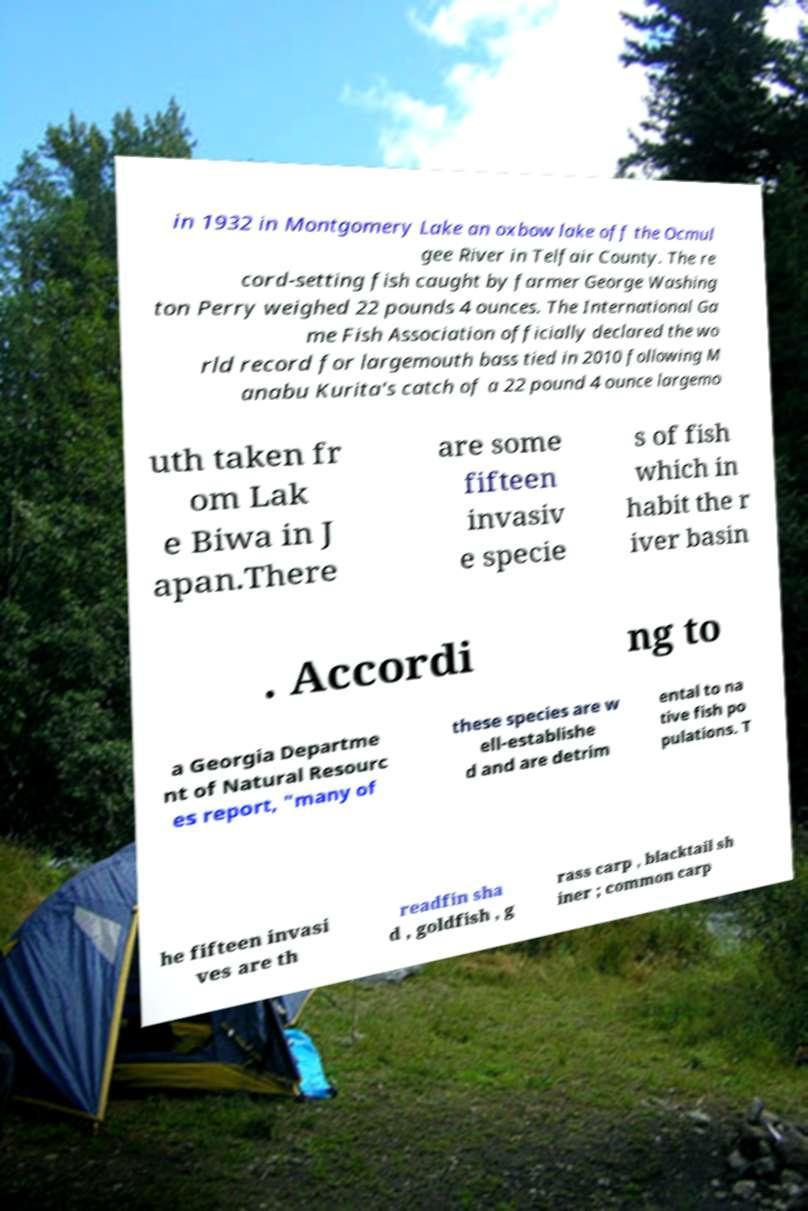Can you read and provide the text displayed in the image?This photo seems to have some interesting text. Can you extract and type it out for me? in 1932 in Montgomery Lake an oxbow lake off the Ocmul gee River in Telfair County. The re cord-setting fish caught by farmer George Washing ton Perry weighed 22 pounds 4 ounces. The International Ga me Fish Association officially declared the wo rld record for largemouth bass tied in 2010 following M anabu Kurita's catch of a 22 pound 4 ounce largemo uth taken fr om Lak e Biwa in J apan.There are some fifteen invasiv e specie s of fish which in habit the r iver basin . Accordi ng to a Georgia Departme nt of Natural Resourc es report, "many of these species are w ell-establishe d and are detrim ental to na tive fish po pulations. T he fifteen invasi ves are th readfin sha d , goldfish , g rass carp , blacktail sh iner ; common carp 